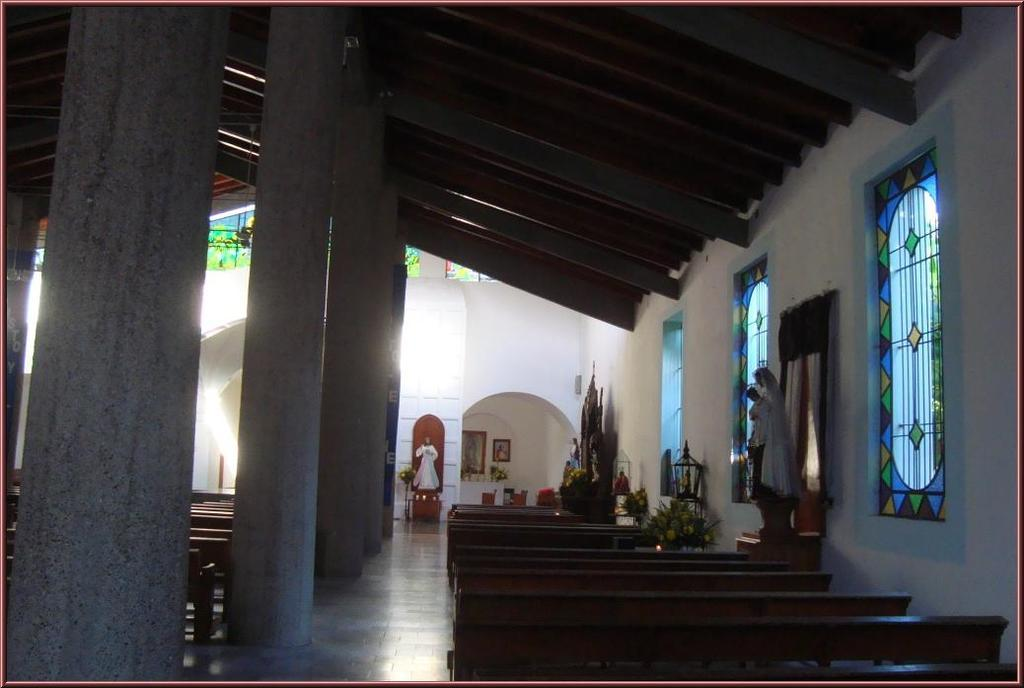What architectural elements can be seen in the image? There are pillars in the image. What type of seating is available in the image? There are benches on the floor in the image. What type of artwork is present in the image? There are statues in the image. What type of vegetation is present in the image? There are plants in the image. What allows natural light to enter the space in the image? There are windows in the image. What type of objects can be seen in the image? There are objects in the image. What type of decorative elements are present on the wall in the background of the image? There are frames on the wall in the background of the image. What type of cap is the partner wearing in the image? There is no partner or cap present in the image. What is the aftermath of the explosion in the image? There is no explosion or aftermath present in the image. 